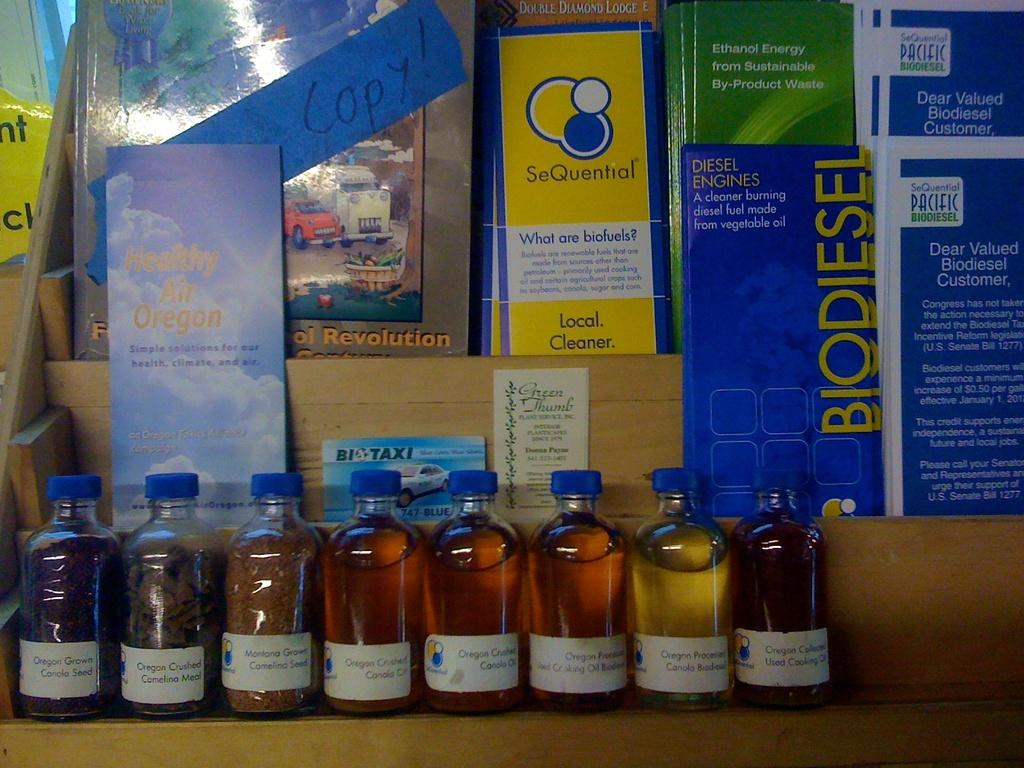Provide a one-sentence caption for the provided image. several small bottles sit on front of a display for Biofuels. 